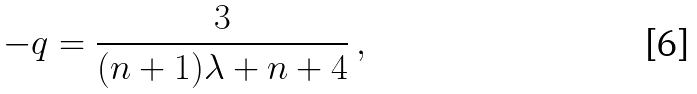Convert formula to latex. <formula><loc_0><loc_0><loc_500><loc_500>- q = \frac { 3 } { ( n + 1 ) \lambda + n + 4 } \, ,</formula> 